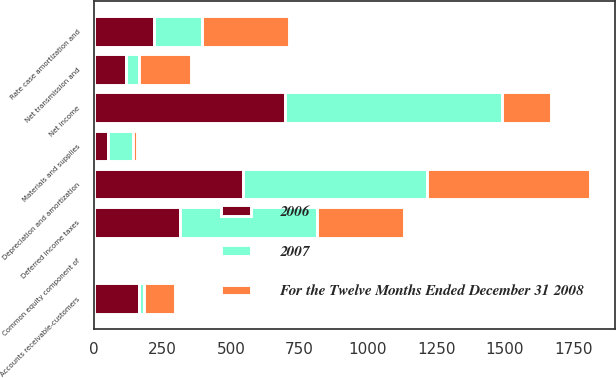Convert chart to OTSL. <chart><loc_0><loc_0><loc_500><loc_500><stacked_bar_chart><ecel><fcel>Net income<fcel>Depreciation and amortization<fcel>Deferred income taxes<fcel>Rate case amortization and<fcel>Net transmission and<fcel>Common equity component of<fcel>Accounts receivable-customers<fcel>Materials and supplies<nl><fcel>2007<fcel>794<fcel>672<fcel>500<fcel>176<fcel>50<fcel>7<fcel>16<fcel>91<nl><fcel>For the Twelve Months Ended December 31 2008<fcel>176<fcel>593<fcel>320<fcel>316<fcel>187<fcel>7<fcel>116<fcel>14<nl><fcel>2006<fcel>697<fcel>545<fcel>312<fcel>218<fcel>115<fcel>5<fcel>164<fcel>51<nl></chart> 